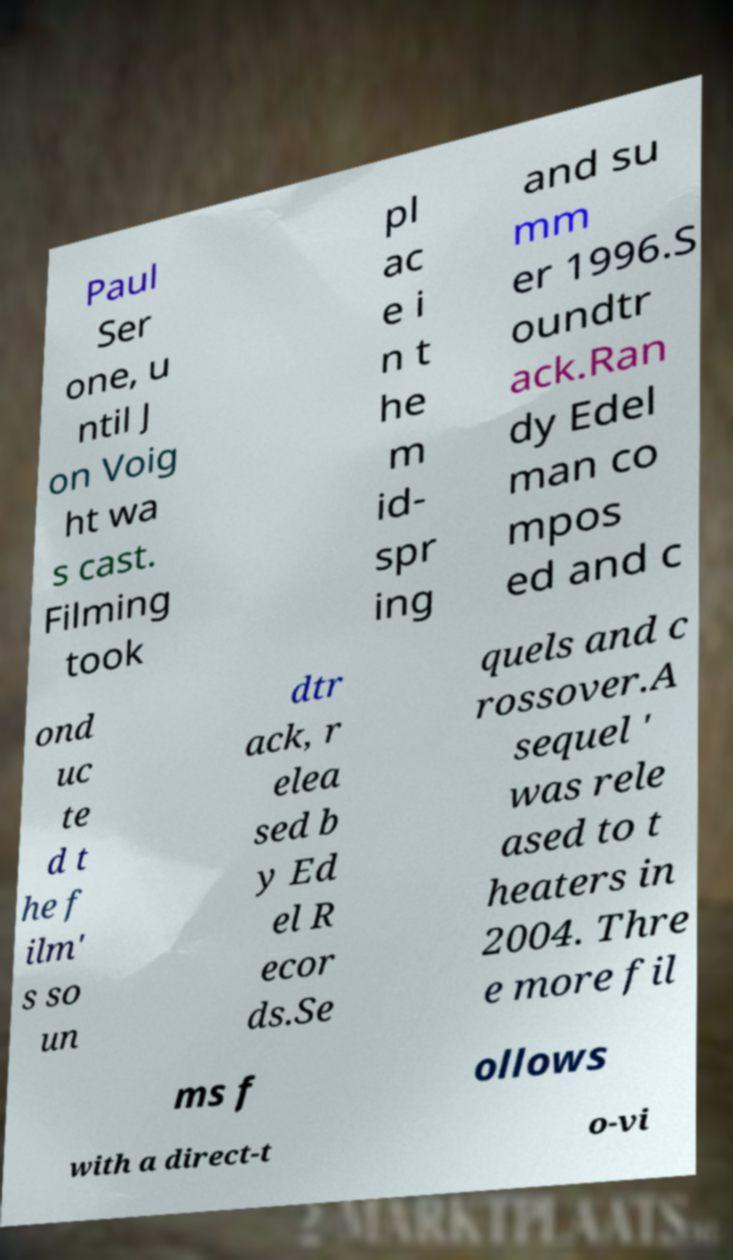There's text embedded in this image that I need extracted. Can you transcribe it verbatim? Paul Ser one, u ntil J on Voig ht wa s cast. Filming took pl ac e i n t he m id- spr ing and su mm er 1996.S oundtr ack.Ran dy Edel man co mpos ed and c ond uc te d t he f ilm' s so un dtr ack, r elea sed b y Ed el R ecor ds.Se quels and c rossover.A sequel ' was rele ased to t heaters in 2004. Thre e more fil ms f ollows with a direct-t o-vi 